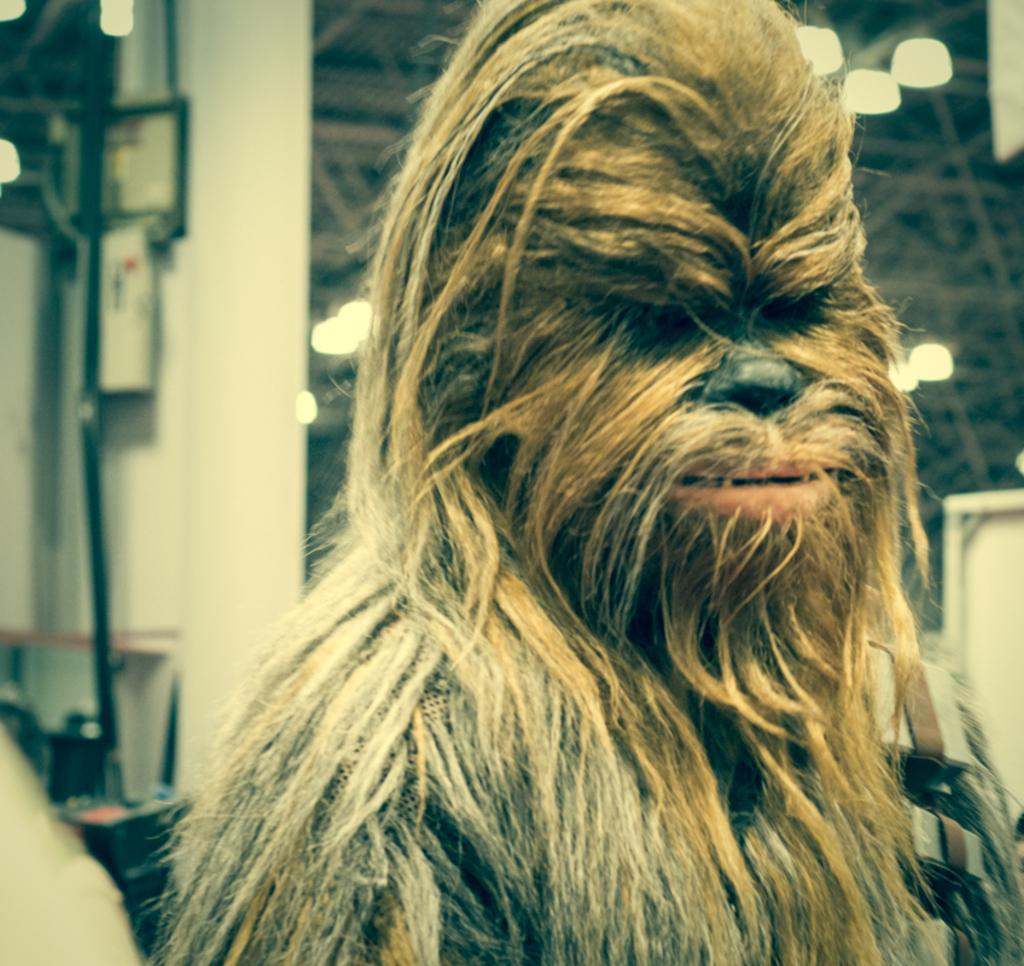Who is the main character in the image? There is a Star Wars character, Chewbacca, in the image. What can be seen in the background of the image? There is a wall, poles, lights, and other unspecified objects in the background of the image. What type of servant can be seen assisting Chewbacca in the image? There is no servant present in the image; it only features Chewbacca. Can you see a monkey interacting with Chewbacca in the image? There is no monkey present in the image; it only features Chewbacca. 